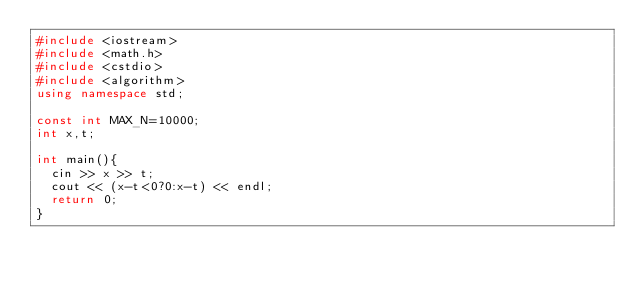<code> <loc_0><loc_0><loc_500><loc_500><_C++_>#include <iostream>
#include <math.h>
#include <cstdio>
#include <algorithm>
using namespace std;

const int MAX_N=10000;
int x,t;

int main(){
	cin >> x >> t;
	cout << (x-t<0?0:x-t) << endl;
	return 0;
}
</code> 